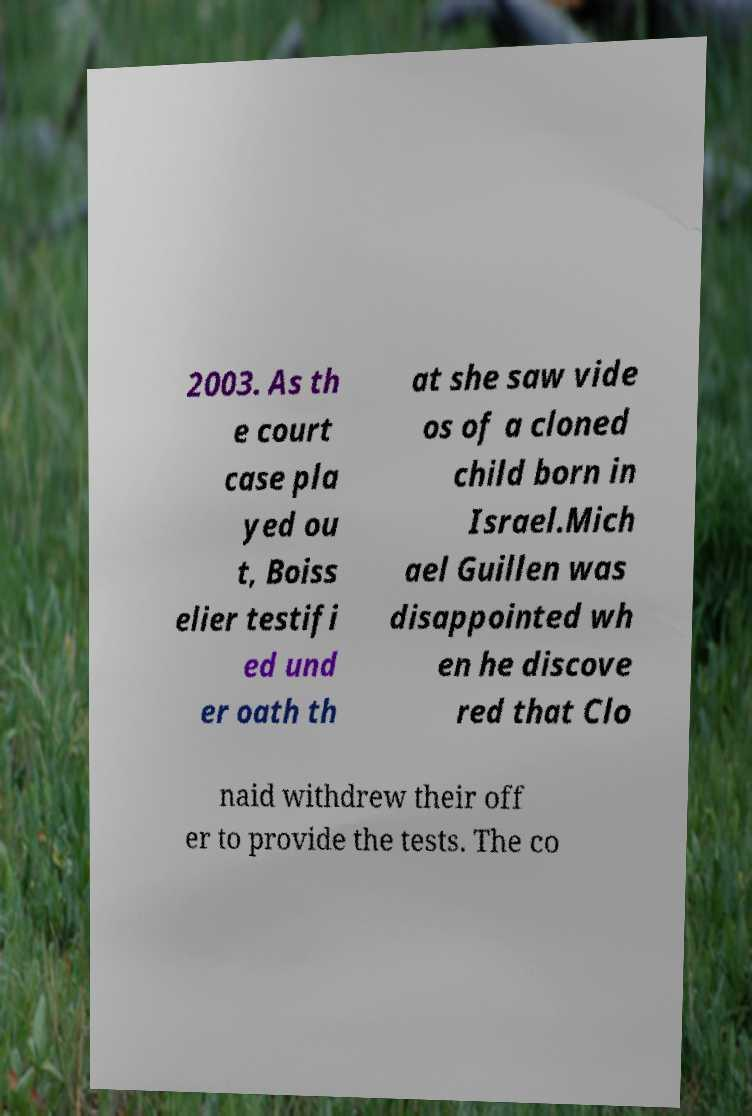Can you accurately transcribe the text from the provided image for me? 2003. As th e court case pla yed ou t, Boiss elier testifi ed und er oath th at she saw vide os of a cloned child born in Israel.Mich ael Guillen was disappointed wh en he discove red that Clo naid withdrew their off er to provide the tests. The co 